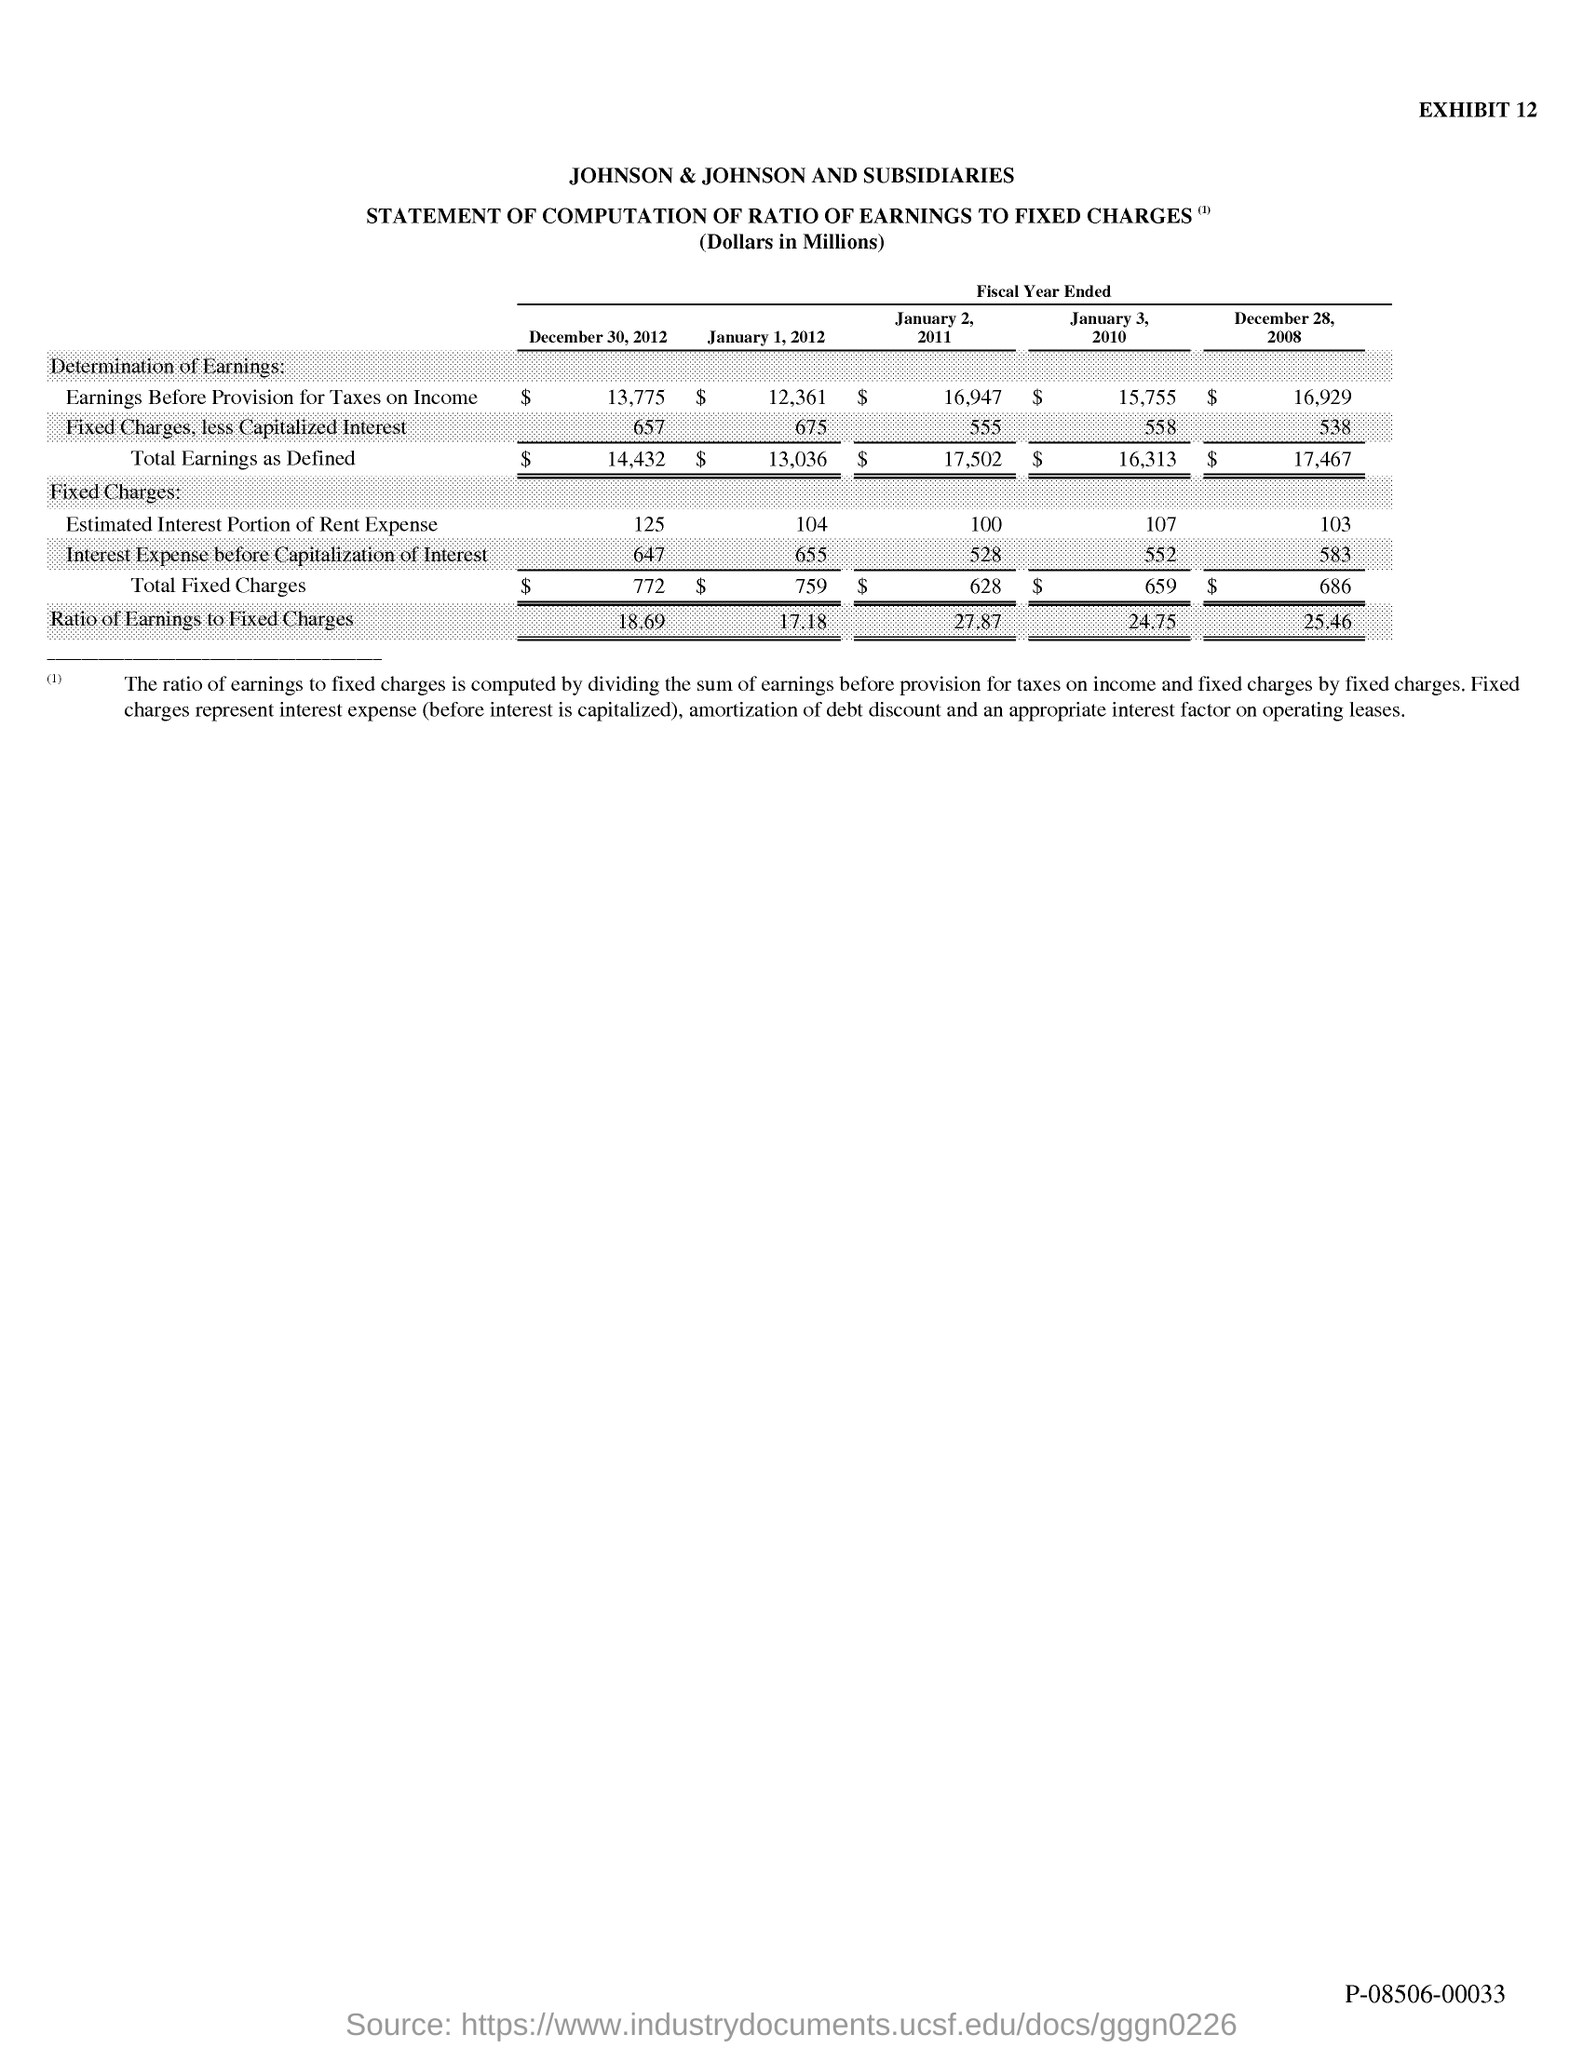What is the exhibit no.?
Your answer should be very brief. 12. 